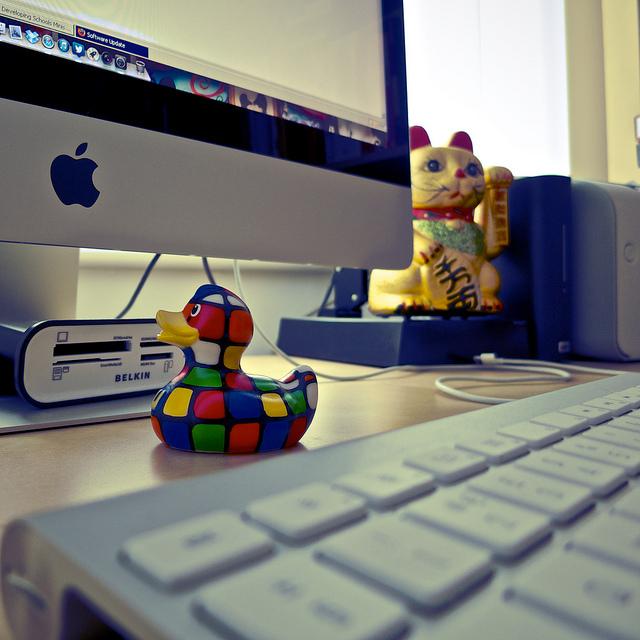Does the cat bring good luck or bad luck?
Concise answer only. Good. What stuffed animal is on the desk?
Be succinct. Duck. What name brand is the monitor?
Write a very short answer. Apple. Is the white cord from the computer connected to anything?
Be succinct. Yes. What does the duck look like?
Keep it brief. Rubix cube. There are two what?
Concise answer only. Toys. 